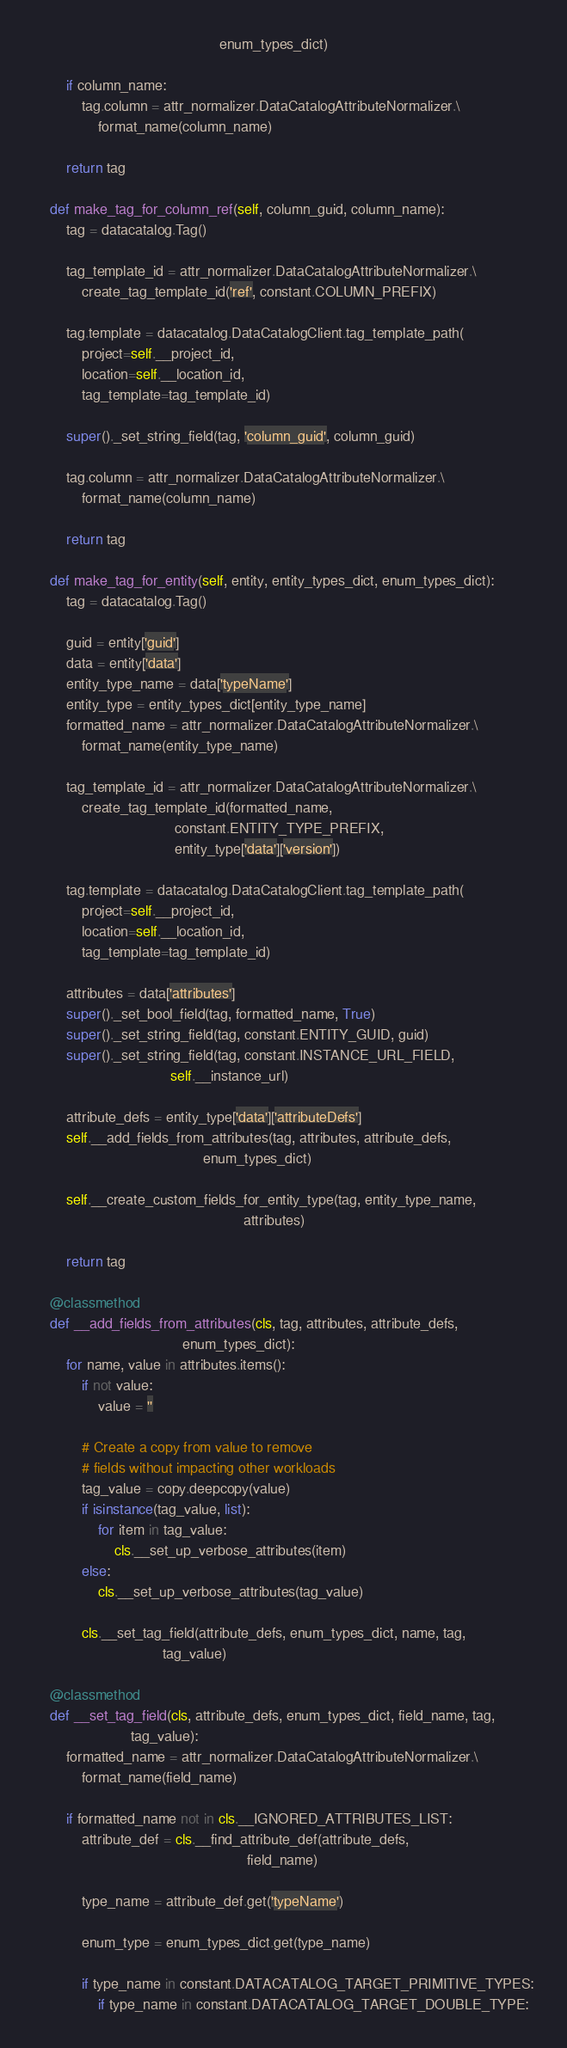<code> <loc_0><loc_0><loc_500><loc_500><_Python_>                                              enum_types_dict)

        if column_name:
            tag.column = attr_normalizer.DataCatalogAttributeNormalizer.\
                format_name(column_name)

        return tag

    def make_tag_for_column_ref(self, column_guid, column_name):
        tag = datacatalog.Tag()

        tag_template_id = attr_normalizer.DataCatalogAttributeNormalizer.\
            create_tag_template_id('ref', constant.COLUMN_PREFIX)

        tag.template = datacatalog.DataCatalogClient.tag_template_path(
            project=self.__project_id,
            location=self.__location_id,
            tag_template=tag_template_id)

        super()._set_string_field(tag, 'column_guid', column_guid)

        tag.column = attr_normalizer.DataCatalogAttributeNormalizer.\
            format_name(column_name)

        return tag

    def make_tag_for_entity(self, entity, entity_types_dict, enum_types_dict):
        tag = datacatalog.Tag()

        guid = entity['guid']
        data = entity['data']
        entity_type_name = data['typeName']
        entity_type = entity_types_dict[entity_type_name]
        formatted_name = attr_normalizer.DataCatalogAttributeNormalizer.\
            format_name(entity_type_name)

        tag_template_id = attr_normalizer.DataCatalogAttributeNormalizer.\
            create_tag_template_id(formatted_name,
                                   constant.ENTITY_TYPE_PREFIX,
                                   entity_type['data']['version'])

        tag.template = datacatalog.DataCatalogClient.tag_template_path(
            project=self.__project_id,
            location=self.__location_id,
            tag_template=tag_template_id)

        attributes = data['attributes']
        super()._set_bool_field(tag, formatted_name, True)
        super()._set_string_field(tag, constant.ENTITY_GUID, guid)
        super()._set_string_field(tag, constant.INSTANCE_URL_FIELD,
                                  self.__instance_url)

        attribute_defs = entity_type['data']['attributeDefs']
        self.__add_fields_from_attributes(tag, attributes, attribute_defs,
                                          enum_types_dict)

        self.__create_custom_fields_for_entity_type(tag, entity_type_name,
                                                    attributes)

        return tag

    @classmethod
    def __add_fields_from_attributes(cls, tag, attributes, attribute_defs,
                                     enum_types_dict):
        for name, value in attributes.items():
            if not value:
                value = ''

            # Create a copy from value to remove
            # fields without impacting other workloads
            tag_value = copy.deepcopy(value)
            if isinstance(tag_value, list):
                for item in tag_value:
                    cls.__set_up_verbose_attributes(item)
            else:
                cls.__set_up_verbose_attributes(tag_value)

            cls.__set_tag_field(attribute_defs, enum_types_dict, name, tag,
                                tag_value)

    @classmethod
    def __set_tag_field(cls, attribute_defs, enum_types_dict, field_name, tag,
                        tag_value):
        formatted_name = attr_normalizer.DataCatalogAttributeNormalizer.\
            format_name(field_name)

        if formatted_name not in cls.__IGNORED_ATTRIBUTES_LIST:
            attribute_def = cls.__find_attribute_def(attribute_defs,
                                                     field_name)

            type_name = attribute_def.get('typeName')

            enum_type = enum_types_dict.get(type_name)

            if type_name in constant.DATACATALOG_TARGET_PRIMITIVE_TYPES:
                if type_name in constant.DATACATALOG_TARGET_DOUBLE_TYPE:</code> 